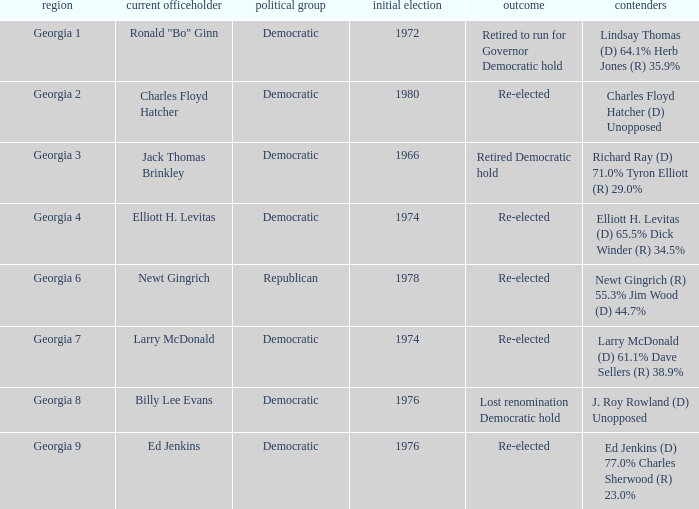Name the districk for larry mcdonald Georgia 7. 